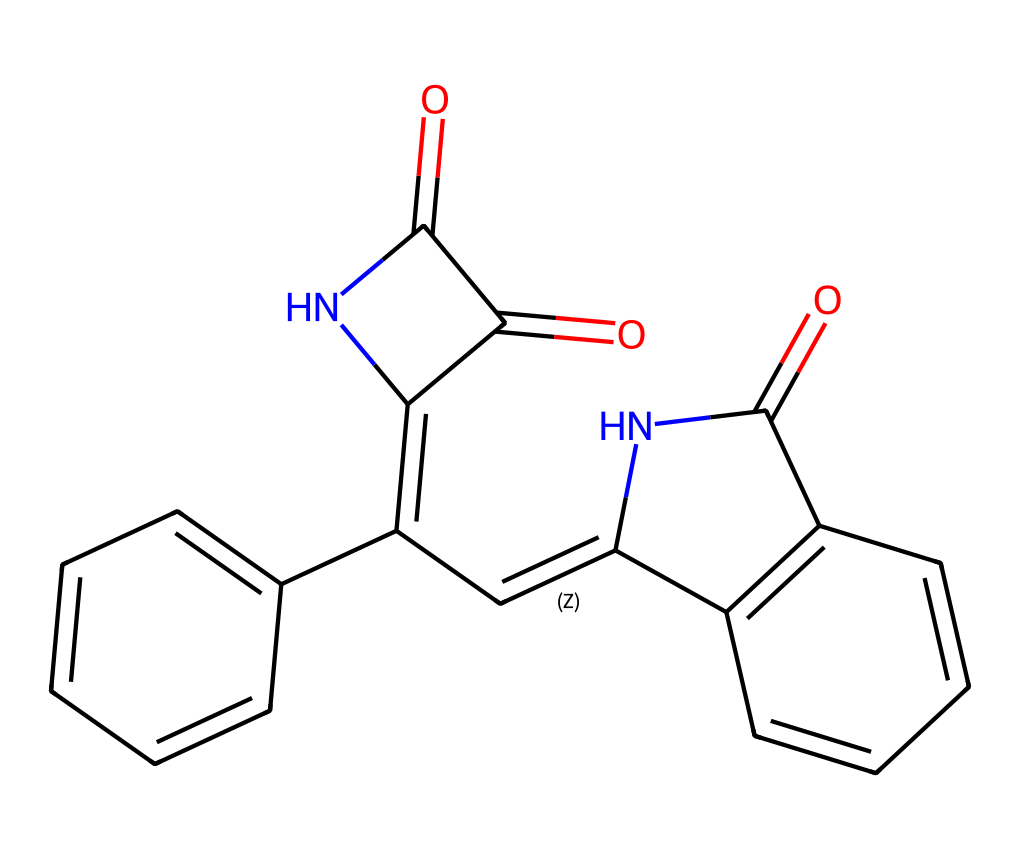What is the molecular formula of this chemical? To determine the molecular formula, count the number of each type of atom represented in the SMILES notation. The components can be counted by identifying carbon (C), nitrogen (N), and oxygen (O) atoms present. There are 16 carbons, 2 nitrogens, and 4 oxygens in the structure.
Answer: C16H10N2O2 How many rings are present in the indigo dye structure? The structure contains multiple cycles. Specifically, there are three interconnected rings in the compound. This can be determined by observing the cyclical connections in the structure.
Answer: 3 What is the functional group represented in this dye? The chemical structure contains two carbonyl (C=O) groups present at the sites indicated in the SMILES. The presence of these functional groups can be confirmed through the presence of the double-bonded oxygen atoms in the structure.
Answer: carbonyl Which type of chemical reaction is this compound primarily associated with? Indigo dye is primarily associated with photochemical reactions, specifically due to its structure that allows for light absorption leading to color changes through excitation. This is inferred by noting its conjugated double bonds, often leading to photochemical behavior.
Answer: photochemical What color does the indigo dye impart to textiles? Indigo dye is known for imparting a deep blue color to textiles, as it is historically used in dyeing fabrics. This is a well-documented property associated with its application in historical dyeing practices.
Answer: blue 